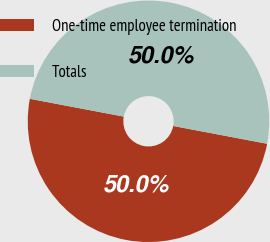Convert chart. <chart><loc_0><loc_0><loc_500><loc_500><pie_chart><fcel>One-time employee termination<fcel>Totals<nl><fcel>50.0%<fcel>50.0%<nl></chart> 